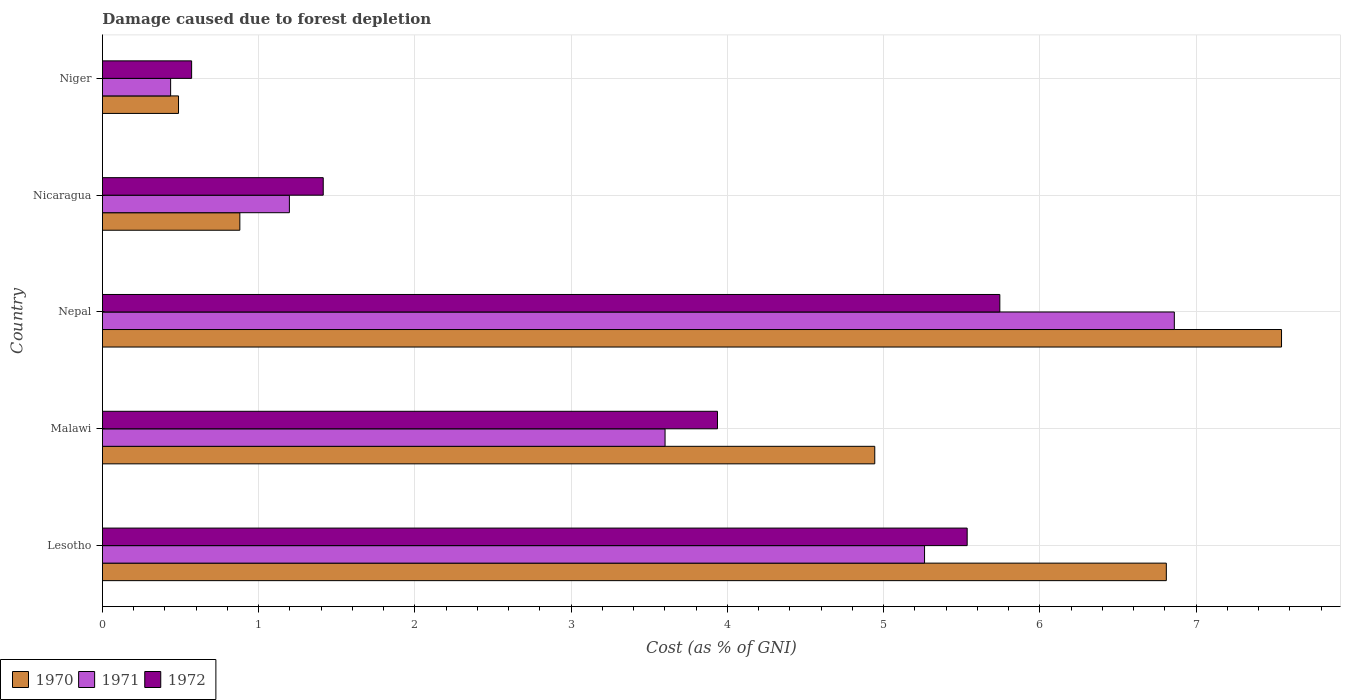Are the number of bars per tick equal to the number of legend labels?
Offer a terse response. Yes. Are the number of bars on each tick of the Y-axis equal?
Ensure brevity in your answer.  Yes. How many bars are there on the 3rd tick from the bottom?
Keep it short and to the point. 3. What is the label of the 4th group of bars from the top?
Offer a terse response. Malawi. In how many cases, is the number of bars for a given country not equal to the number of legend labels?
Your answer should be very brief. 0. What is the cost of damage caused due to forest depletion in 1971 in Nicaragua?
Keep it short and to the point. 1.2. Across all countries, what is the maximum cost of damage caused due to forest depletion in 1970?
Provide a succinct answer. 7.55. Across all countries, what is the minimum cost of damage caused due to forest depletion in 1972?
Keep it short and to the point. 0.57. In which country was the cost of damage caused due to forest depletion in 1972 maximum?
Your response must be concise. Nepal. In which country was the cost of damage caused due to forest depletion in 1972 minimum?
Provide a succinct answer. Niger. What is the total cost of damage caused due to forest depletion in 1971 in the graph?
Offer a very short reply. 17.36. What is the difference between the cost of damage caused due to forest depletion in 1972 in Nepal and that in Nicaragua?
Keep it short and to the point. 4.33. What is the difference between the cost of damage caused due to forest depletion in 1971 in Malawi and the cost of damage caused due to forest depletion in 1970 in Niger?
Provide a succinct answer. 3.11. What is the average cost of damage caused due to forest depletion in 1970 per country?
Ensure brevity in your answer.  4.13. What is the difference between the cost of damage caused due to forest depletion in 1971 and cost of damage caused due to forest depletion in 1972 in Nepal?
Your answer should be compact. 1.12. What is the ratio of the cost of damage caused due to forest depletion in 1970 in Malawi to that in Nepal?
Ensure brevity in your answer.  0.66. Is the cost of damage caused due to forest depletion in 1970 in Lesotho less than that in Nicaragua?
Your response must be concise. No. Is the difference between the cost of damage caused due to forest depletion in 1971 in Nepal and Niger greater than the difference between the cost of damage caused due to forest depletion in 1972 in Nepal and Niger?
Keep it short and to the point. Yes. What is the difference between the highest and the second highest cost of damage caused due to forest depletion in 1970?
Make the answer very short. 0.74. What is the difference between the highest and the lowest cost of damage caused due to forest depletion in 1972?
Your answer should be very brief. 5.17. In how many countries, is the cost of damage caused due to forest depletion in 1970 greater than the average cost of damage caused due to forest depletion in 1970 taken over all countries?
Your answer should be very brief. 3. Is the sum of the cost of damage caused due to forest depletion in 1970 in Nicaragua and Niger greater than the maximum cost of damage caused due to forest depletion in 1971 across all countries?
Your response must be concise. No. How many bars are there?
Ensure brevity in your answer.  15. How many countries are there in the graph?
Offer a very short reply. 5. What is the difference between two consecutive major ticks on the X-axis?
Provide a short and direct response. 1. Where does the legend appear in the graph?
Your answer should be compact. Bottom left. How many legend labels are there?
Offer a very short reply. 3. What is the title of the graph?
Your answer should be compact. Damage caused due to forest depletion. What is the label or title of the X-axis?
Your answer should be compact. Cost (as % of GNI). What is the label or title of the Y-axis?
Ensure brevity in your answer.  Country. What is the Cost (as % of GNI) in 1970 in Lesotho?
Your answer should be compact. 6.81. What is the Cost (as % of GNI) of 1971 in Lesotho?
Offer a very short reply. 5.26. What is the Cost (as % of GNI) of 1972 in Lesotho?
Give a very brief answer. 5.53. What is the Cost (as % of GNI) in 1970 in Malawi?
Offer a very short reply. 4.94. What is the Cost (as % of GNI) of 1971 in Malawi?
Your answer should be compact. 3.6. What is the Cost (as % of GNI) in 1972 in Malawi?
Your response must be concise. 3.94. What is the Cost (as % of GNI) of 1970 in Nepal?
Provide a succinct answer. 7.55. What is the Cost (as % of GNI) of 1971 in Nepal?
Keep it short and to the point. 6.86. What is the Cost (as % of GNI) in 1972 in Nepal?
Provide a short and direct response. 5.74. What is the Cost (as % of GNI) of 1970 in Nicaragua?
Offer a terse response. 0.88. What is the Cost (as % of GNI) in 1971 in Nicaragua?
Offer a very short reply. 1.2. What is the Cost (as % of GNI) in 1972 in Nicaragua?
Your answer should be compact. 1.41. What is the Cost (as % of GNI) of 1970 in Niger?
Your answer should be compact. 0.49. What is the Cost (as % of GNI) in 1971 in Niger?
Make the answer very short. 0.44. What is the Cost (as % of GNI) of 1972 in Niger?
Ensure brevity in your answer.  0.57. Across all countries, what is the maximum Cost (as % of GNI) of 1970?
Keep it short and to the point. 7.55. Across all countries, what is the maximum Cost (as % of GNI) of 1971?
Keep it short and to the point. 6.86. Across all countries, what is the maximum Cost (as % of GNI) of 1972?
Your answer should be compact. 5.74. Across all countries, what is the minimum Cost (as % of GNI) of 1970?
Keep it short and to the point. 0.49. Across all countries, what is the minimum Cost (as % of GNI) in 1971?
Make the answer very short. 0.44. Across all countries, what is the minimum Cost (as % of GNI) in 1972?
Offer a very short reply. 0.57. What is the total Cost (as % of GNI) in 1970 in the graph?
Provide a succinct answer. 20.67. What is the total Cost (as % of GNI) in 1971 in the graph?
Ensure brevity in your answer.  17.36. What is the total Cost (as % of GNI) of 1972 in the graph?
Your answer should be compact. 17.2. What is the difference between the Cost (as % of GNI) of 1970 in Lesotho and that in Malawi?
Provide a succinct answer. 1.87. What is the difference between the Cost (as % of GNI) in 1971 in Lesotho and that in Malawi?
Give a very brief answer. 1.66. What is the difference between the Cost (as % of GNI) of 1972 in Lesotho and that in Malawi?
Make the answer very short. 1.6. What is the difference between the Cost (as % of GNI) in 1970 in Lesotho and that in Nepal?
Provide a short and direct response. -0.74. What is the difference between the Cost (as % of GNI) in 1971 in Lesotho and that in Nepal?
Your answer should be very brief. -1.6. What is the difference between the Cost (as % of GNI) of 1972 in Lesotho and that in Nepal?
Make the answer very short. -0.21. What is the difference between the Cost (as % of GNI) in 1970 in Lesotho and that in Nicaragua?
Make the answer very short. 5.93. What is the difference between the Cost (as % of GNI) in 1971 in Lesotho and that in Nicaragua?
Your response must be concise. 4.07. What is the difference between the Cost (as % of GNI) of 1972 in Lesotho and that in Nicaragua?
Give a very brief answer. 4.12. What is the difference between the Cost (as % of GNI) of 1970 in Lesotho and that in Niger?
Provide a short and direct response. 6.32. What is the difference between the Cost (as % of GNI) in 1971 in Lesotho and that in Niger?
Make the answer very short. 4.83. What is the difference between the Cost (as % of GNI) of 1972 in Lesotho and that in Niger?
Your answer should be compact. 4.96. What is the difference between the Cost (as % of GNI) in 1970 in Malawi and that in Nepal?
Your answer should be compact. -2.6. What is the difference between the Cost (as % of GNI) in 1971 in Malawi and that in Nepal?
Your response must be concise. -3.26. What is the difference between the Cost (as % of GNI) of 1972 in Malawi and that in Nepal?
Offer a very short reply. -1.81. What is the difference between the Cost (as % of GNI) of 1970 in Malawi and that in Nicaragua?
Keep it short and to the point. 4.06. What is the difference between the Cost (as % of GNI) in 1971 in Malawi and that in Nicaragua?
Give a very brief answer. 2.4. What is the difference between the Cost (as % of GNI) of 1972 in Malawi and that in Nicaragua?
Make the answer very short. 2.52. What is the difference between the Cost (as % of GNI) in 1970 in Malawi and that in Niger?
Offer a very short reply. 4.46. What is the difference between the Cost (as % of GNI) in 1971 in Malawi and that in Niger?
Offer a very short reply. 3.16. What is the difference between the Cost (as % of GNI) in 1972 in Malawi and that in Niger?
Make the answer very short. 3.37. What is the difference between the Cost (as % of GNI) in 1970 in Nepal and that in Nicaragua?
Your response must be concise. 6.67. What is the difference between the Cost (as % of GNI) in 1971 in Nepal and that in Nicaragua?
Your answer should be compact. 5.66. What is the difference between the Cost (as % of GNI) of 1972 in Nepal and that in Nicaragua?
Provide a succinct answer. 4.33. What is the difference between the Cost (as % of GNI) in 1970 in Nepal and that in Niger?
Your answer should be compact. 7.06. What is the difference between the Cost (as % of GNI) in 1971 in Nepal and that in Niger?
Keep it short and to the point. 6.42. What is the difference between the Cost (as % of GNI) of 1972 in Nepal and that in Niger?
Your answer should be very brief. 5.17. What is the difference between the Cost (as % of GNI) in 1970 in Nicaragua and that in Niger?
Make the answer very short. 0.39. What is the difference between the Cost (as % of GNI) of 1971 in Nicaragua and that in Niger?
Your answer should be very brief. 0.76. What is the difference between the Cost (as % of GNI) in 1972 in Nicaragua and that in Niger?
Keep it short and to the point. 0.84. What is the difference between the Cost (as % of GNI) in 1970 in Lesotho and the Cost (as % of GNI) in 1971 in Malawi?
Provide a succinct answer. 3.21. What is the difference between the Cost (as % of GNI) in 1970 in Lesotho and the Cost (as % of GNI) in 1972 in Malawi?
Provide a succinct answer. 2.87. What is the difference between the Cost (as % of GNI) in 1971 in Lesotho and the Cost (as % of GNI) in 1972 in Malawi?
Keep it short and to the point. 1.33. What is the difference between the Cost (as % of GNI) of 1970 in Lesotho and the Cost (as % of GNI) of 1971 in Nepal?
Offer a terse response. -0.05. What is the difference between the Cost (as % of GNI) in 1970 in Lesotho and the Cost (as % of GNI) in 1972 in Nepal?
Provide a short and direct response. 1.07. What is the difference between the Cost (as % of GNI) in 1971 in Lesotho and the Cost (as % of GNI) in 1972 in Nepal?
Your answer should be very brief. -0.48. What is the difference between the Cost (as % of GNI) of 1970 in Lesotho and the Cost (as % of GNI) of 1971 in Nicaragua?
Ensure brevity in your answer.  5.61. What is the difference between the Cost (as % of GNI) in 1970 in Lesotho and the Cost (as % of GNI) in 1972 in Nicaragua?
Give a very brief answer. 5.4. What is the difference between the Cost (as % of GNI) of 1971 in Lesotho and the Cost (as % of GNI) of 1972 in Nicaragua?
Ensure brevity in your answer.  3.85. What is the difference between the Cost (as % of GNI) in 1970 in Lesotho and the Cost (as % of GNI) in 1971 in Niger?
Your answer should be compact. 6.37. What is the difference between the Cost (as % of GNI) in 1970 in Lesotho and the Cost (as % of GNI) in 1972 in Niger?
Provide a succinct answer. 6.24. What is the difference between the Cost (as % of GNI) of 1971 in Lesotho and the Cost (as % of GNI) of 1972 in Niger?
Provide a short and direct response. 4.69. What is the difference between the Cost (as % of GNI) in 1970 in Malawi and the Cost (as % of GNI) in 1971 in Nepal?
Your response must be concise. -1.92. What is the difference between the Cost (as % of GNI) of 1970 in Malawi and the Cost (as % of GNI) of 1972 in Nepal?
Make the answer very short. -0.8. What is the difference between the Cost (as % of GNI) of 1971 in Malawi and the Cost (as % of GNI) of 1972 in Nepal?
Keep it short and to the point. -2.14. What is the difference between the Cost (as % of GNI) of 1970 in Malawi and the Cost (as % of GNI) of 1971 in Nicaragua?
Give a very brief answer. 3.75. What is the difference between the Cost (as % of GNI) in 1970 in Malawi and the Cost (as % of GNI) in 1972 in Nicaragua?
Your answer should be compact. 3.53. What is the difference between the Cost (as % of GNI) of 1971 in Malawi and the Cost (as % of GNI) of 1972 in Nicaragua?
Make the answer very short. 2.19. What is the difference between the Cost (as % of GNI) of 1970 in Malawi and the Cost (as % of GNI) of 1971 in Niger?
Your answer should be compact. 4.51. What is the difference between the Cost (as % of GNI) in 1970 in Malawi and the Cost (as % of GNI) in 1972 in Niger?
Make the answer very short. 4.37. What is the difference between the Cost (as % of GNI) in 1971 in Malawi and the Cost (as % of GNI) in 1972 in Niger?
Your answer should be compact. 3.03. What is the difference between the Cost (as % of GNI) of 1970 in Nepal and the Cost (as % of GNI) of 1971 in Nicaragua?
Your answer should be very brief. 6.35. What is the difference between the Cost (as % of GNI) of 1970 in Nepal and the Cost (as % of GNI) of 1972 in Nicaragua?
Provide a short and direct response. 6.13. What is the difference between the Cost (as % of GNI) in 1971 in Nepal and the Cost (as % of GNI) in 1972 in Nicaragua?
Offer a very short reply. 5.45. What is the difference between the Cost (as % of GNI) in 1970 in Nepal and the Cost (as % of GNI) in 1971 in Niger?
Your answer should be very brief. 7.11. What is the difference between the Cost (as % of GNI) in 1970 in Nepal and the Cost (as % of GNI) in 1972 in Niger?
Make the answer very short. 6.98. What is the difference between the Cost (as % of GNI) of 1971 in Nepal and the Cost (as % of GNI) of 1972 in Niger?
Offer a very short reply. 6.29. What is the difference between the Cost (as % of GNI) of 1970 in Nicaragua and the Cost (as % of GNI) of 1971 in Niger?
Give a very brief answer. 0.44. What is the difference between the Cost (as % of GNI) of 1970 in Nicaragua and the Cost (as % of GNI) of 1972 in Niger?
Give a very brief answer. 0.31. What is the difference between the Cost (as % of GNI) of 1971 in Nicaragua and the Cost (as % of GNI) of 1972 in Niger?
Offer a very short reply. 0.63. What is the average Cost (as % of GNI) of 1970 per country?
Make the answer very short. 4.13. What is the average Cost (as % of GNI) of 1971 per country?
Offer a terse response. 3.47. What is the average Cost (as % of GNI) in 1972 per country?
Your response must be concise. 3.44. What is the difference between the Cost (as % of GNI) of 1970 and Cost (as % of GNI) of 1971 in Lesotho?
Offer a terse response. 1.55. What is the difference between the Cost (as % of GNI) of 1970 and Cost (as % of GNI) of 1972 in Lesotho?
Your answer should be very brief. 1.27. What is the difference between the Cost (as % of GNI) of 1971 and Cost (as % of GNI) of 1972 in Lesotho?
Make the answer very short. -0.27. What is the difference between the Cost (as % of GNI) of 1970 and Cost (as % of GNI) of 1971 in Malawi?
Give a very brief answer. 1.34. What is the difference between the Cost (as % of GNI) of 1970 and Cost (as % of GNI) of 1972 in Malawi?
Your response must be concise. 1.01. What is the difference between the Cost (as % of GNI) in 1971 and Cost (as % of GNI) in 1972 in Malawi?
Provide a short and direct response. -0.34. What is the difference between the Cost (as % of GNI) of 1970 and Cost (as % of GNI) of 1971 in Nepal?
Keep it short and to the point. 0.69. What is the difference between the Cost (as % of GNI) of 1970 and Cost (as % of GNI) of 1972 in Nepal?
Offer a terse response. 1.8. What is the difference between the Cost (as % of GNI) of 1971 and Cost (as % of GNI) of 1972 in Nepal?
Your response must be concise. 1.12. What is the difference between the Cost (as % of GNI) of 1970 and Cost (as % of GNI) of 1971 in Nicaragua?
Your response must be concise. -0.32. What is the difference between the Cost (as % of GNI) of 1970 and Cost (as % of GNI) of 1972 in Nicaragua?
Provide a short and direct response. -0.53. What is the difference between the Cost (as % of GNI) in 1971 and Cost (as % of GNI) in 1972 in Nicaragua?
Your response must be concise. -0.22. What is the difference between the Cost (as % of GNI) of 1970 and Cost (as % of GNI) of 1971 in Niger?
Ensure brevity in your answer.  0.05. What is the difference between the Cost (as % of GNI) in 1970 and Cost (as % of GNI) in 1972 in Niger?
Your answer should be very brief. -0.08. What is the difference between the Cost (as % of GNI) in 1971 and Cost (as % of GNI) in 1972 in Niger?
Provide a succinct answer. -0.13. What is the ratio of the Cost (as % of GNI) in 1970 in Lesotho to that in Malawi?
Your response must be concise. 1.38. What is the ratio of the Cost (as % of GNI) of 1971 in Lesotho to that in Malawi?
Ensure brevity in your answer.  1.46. What is the ratio of the Cost (as % of GNI) in 1972 in Lesotho to that in Malawi?
Keep it short and to the point. 1.41. What is the ratio of the Cost (as % of GNI) of 1970 in Lesotho to that in Nepal?
Give a very brief answer. 0.9. What is the ratio of the Cost (as % of GNI) in 1971 in Lesotho to that in Nepal?
Give a very brief answer. 0.77. What is the ratio of the Cost (as % of GNI) in 1972 in Lesotho to that in Nepal?
Your answer should be compact. 0.96. What is the ratio of the Cost (as % of GNI) in 1970 in Lesotho to that in Nicaragua?
Your response must be concise. 7.74. What is the ratio of the Cost (as % of GNI) of 1971 in Lesotho to that in Nicaragua?
Give a very brief answer. 4.4. What is the ratio of the Cost (as % of GNI) in 1972 in Lesotho to that in Nicaragua?
Ensure brevity in your answer.  3.92. What is the ratio of the Cost (as % of GNI) of 1970 in Lesotho to that in Niger?
Your response must be concise. 13.99. What is the ratio of the Cost (as % of GNI) of 1971 in Lesotho to that in Niger?
Offer a very short reply. 12.06. What is the ratio of the Cost (as % of GNI) in 1972 in Lesotho to that in Niger?
Offer a very short reply. 9.7. What is the ratio of the Cost (as % of GNI) in 1970 in Malawi to that in Nepal?
Offer a terse response. 0.66. What is the ratio of the Cost (as % of GNI) of 1971 in Malawi to that in Nepal?
Keep it short and to the point. 0.52. What is the ratio of the Cost (as % of GNI) in 1972 in Malawi to that in Nepal?
Provide a succinct answer. 0.69. What is the ratio of the Cost (as % of GNI) in 1970 in Malawi to that in Nicaragua?
Provide a succinct answer. 5.62. What is the ratio of the Cost (as % of GNI) of 1971 in Malawi to that in Nicaragua?
Provide a succinct answer. 3.01. What is the ratio of the Cost (as % of GNI) of 1972 in Malawi to that in Nicaragua?
Keep it short and to the point. 2.79. What is the ratio of the Cost (as % of GNI) of 1970 in Malawi to that in Niger?
Your response must be concise. 10.15. What is the ratio of the Cost (as % of GNI) in 1971 in Malawi to that in Niger?
Your answer should be very brief. 8.26. What is the ratio of the Cost (as % of GNI) in 1972 in Malawi to that in Niger?
Keep it short and to the point. 6.9. What is the ratio of the Cost (as % of GNI) in 1970 in Nepal to that in Nicaragua?
Make the answer very short. 8.58. What is the ratio of the Cost (as % of GNI) of 1971 in Nepal to that in Nicaragua?
Your response must be concise. 5.73. What is the ratio of the Cost (as % of GNI) in 1972 in Nepal to that in Nicaragua?
Your answer should be very brief. 4.06. What is the ratio of the Cost (as % of GNI) of 1970 in Nepal to that in Niger?
Give a very brief answer. 15.5. What is the ratio of the Cost (as % of GNI) in 1971 in Nepal to that in Niger?
Keep it short and to the point. 15.73. What is the ratio of the Cost (as % of GNI) in 1972 in Nepal to that in Niger?
Your response must be concise. 10.06. What is the ratio of the Cost (as % of GNI) in 1970 in Nicaragua to that in Niger?
Ensure brevity in your answer.  1.81. What is the ratio of the Cost (as % of GNI) of 1971 in Nicaragua to that in Niger?
Provide a short and direct response. 2.74. What is the ratio of the Cost (as % of GNI) of 1972 in Nicaragua to that in Niger?
Provide a succinct answer. 2.48. What is the difference between the highest and the second highest Cost (as % of GNI) of 1970?
Make the answer very short. 0.74. What is the difference between the highest and the second highest Cost (as % of GNI) of 1971?
Offer a very short reply. 1.6. What is the difference between the highest and the second highest Cost (as % of GNI) of 1972?
Offer a very short reply. 0.21. What is the difference between the highest and the lowest Cost (as % of GNI) in 1970?
Make the answer very short. 7.06. What is the difference between the highest and the lowest Cost (as % of GNI) of 1971?
Ensure brevity in your answer.  6.42. What is the difference between the highest and the lowest Cost (as % of GNI) in 1972?
Ensure brevity in your answer.  5.17. 